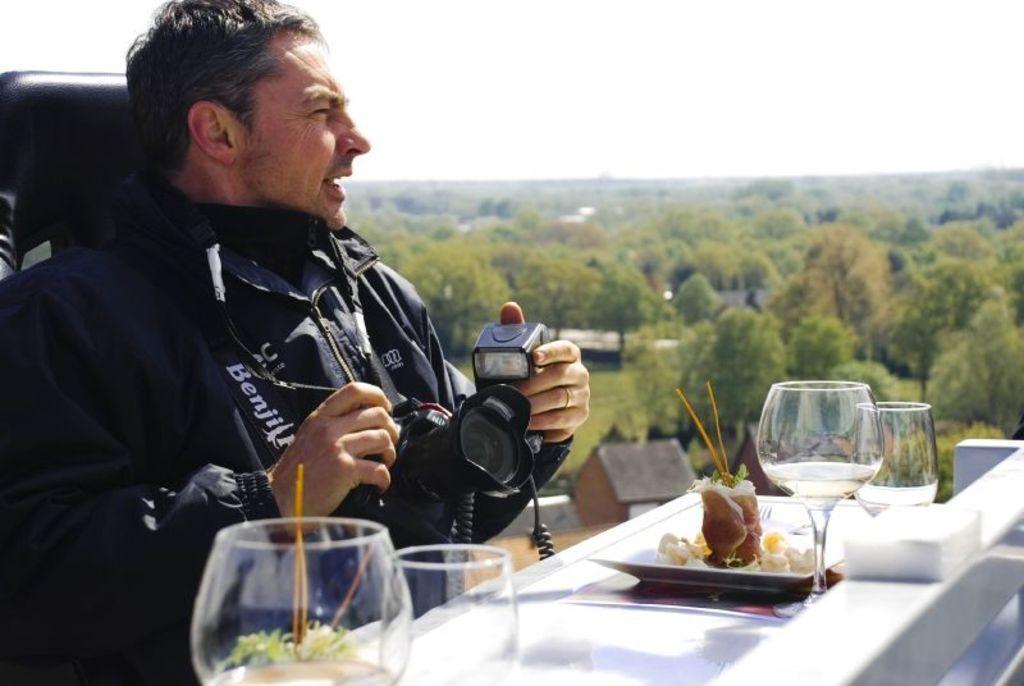Can you describe this image briefly? As we can see in the image there is a sky, trees, a man sitting on chair and holding camera in his hand and there is a table over here. On table there are glasses. 